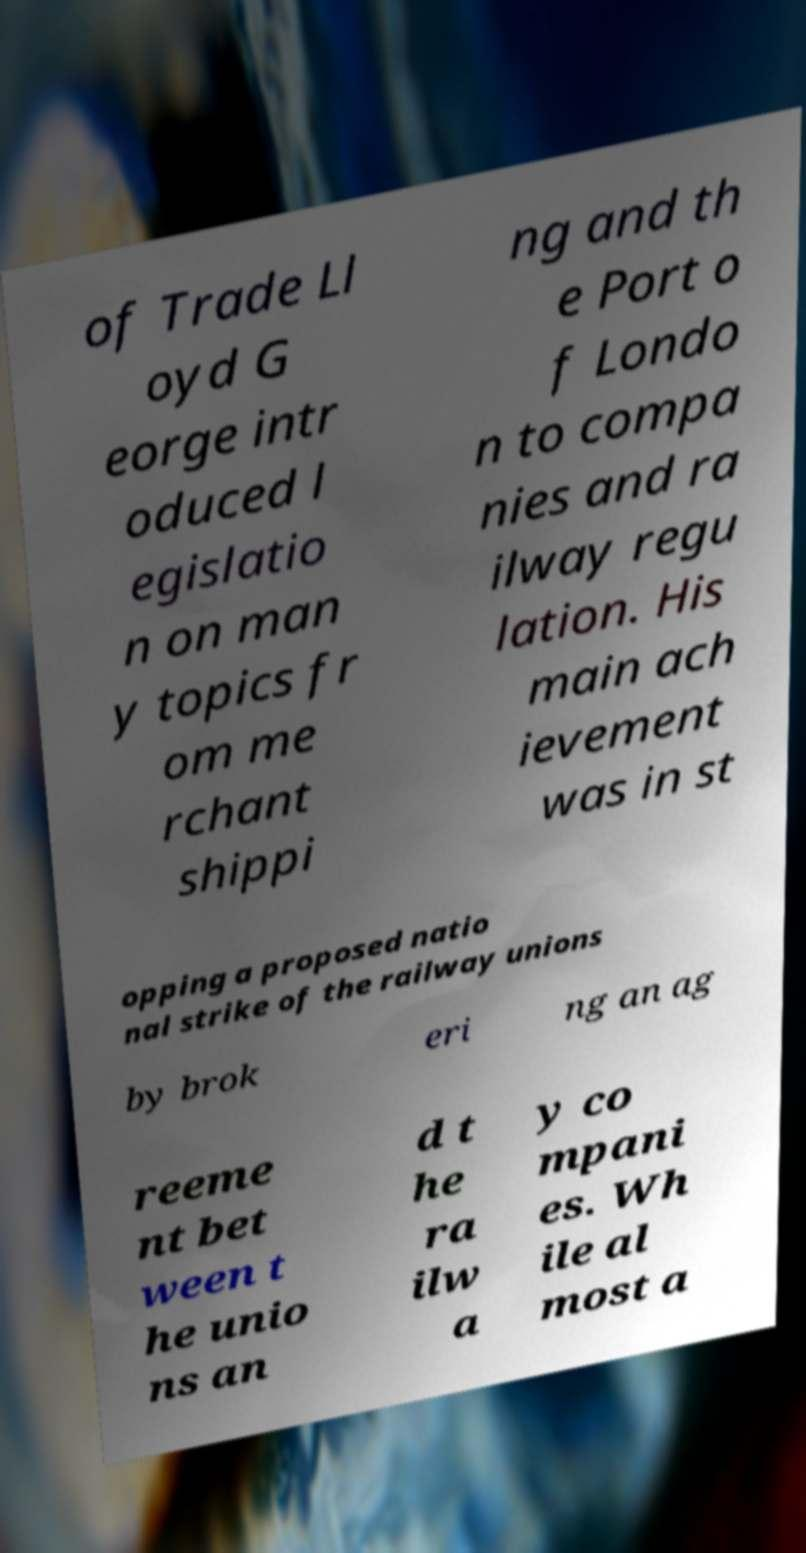For documentation purposes, I need the text within this image transcribed. Could you provide that? of Trade Ll oyd G eorge intr oduced l egislatio n on man y topics fr om me rchant shippi ng and th e Port o f Londo n to compa nies and ra ilway regu lation. His main ach ievement was in st opping a proposed natio nal strike of the railway unions by brok eri ng an ag reeme nt bet ween t he unio ns an d t he ra ilw a y co mpani es. Wh ile al most a 